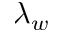Convert formula to latex. <formula><loc_0><loc_0><loc_500><loc_500>\lambda _ { w }</formula> 